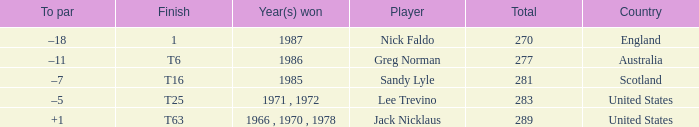What country has a total greater than 270, with sandy lyle as the player? Scotland. Give me the full table as a dictionary. {'header': ['To par', 'Finish', 'Year(s) won', 'Player', 'Total', 'Country'], 'rows': [['–18', '1', '1987', 'Nick Faldo', '270', 'England'], ['–11', 'T6', '1986', 'Greg Norman', '277', 'Australia'], ['–7', 'T16', '1985', 'Sandy Lyle', '281', 'Scotland'], ['–5', 'T25', '1971 , 1972', 'Lee Trevino', '283', 'United States'], ['+1', 'T63', '1966 , 1970 , 1978', 'Jack Nicklaus', '289', 'United States']]} 